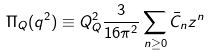<formula> <loc_0><loc_0><loc_500><loc_500>\Pi _ { Q } ( q ^ { 2 } ) \equiv Q _ { Q } ^ { 2 } \frac { 3 } { 1 6 \pi ^ { 2 } } \sum _ { n \geq 0 } \bar { C } _ { n } z ^ { n }</formula> 